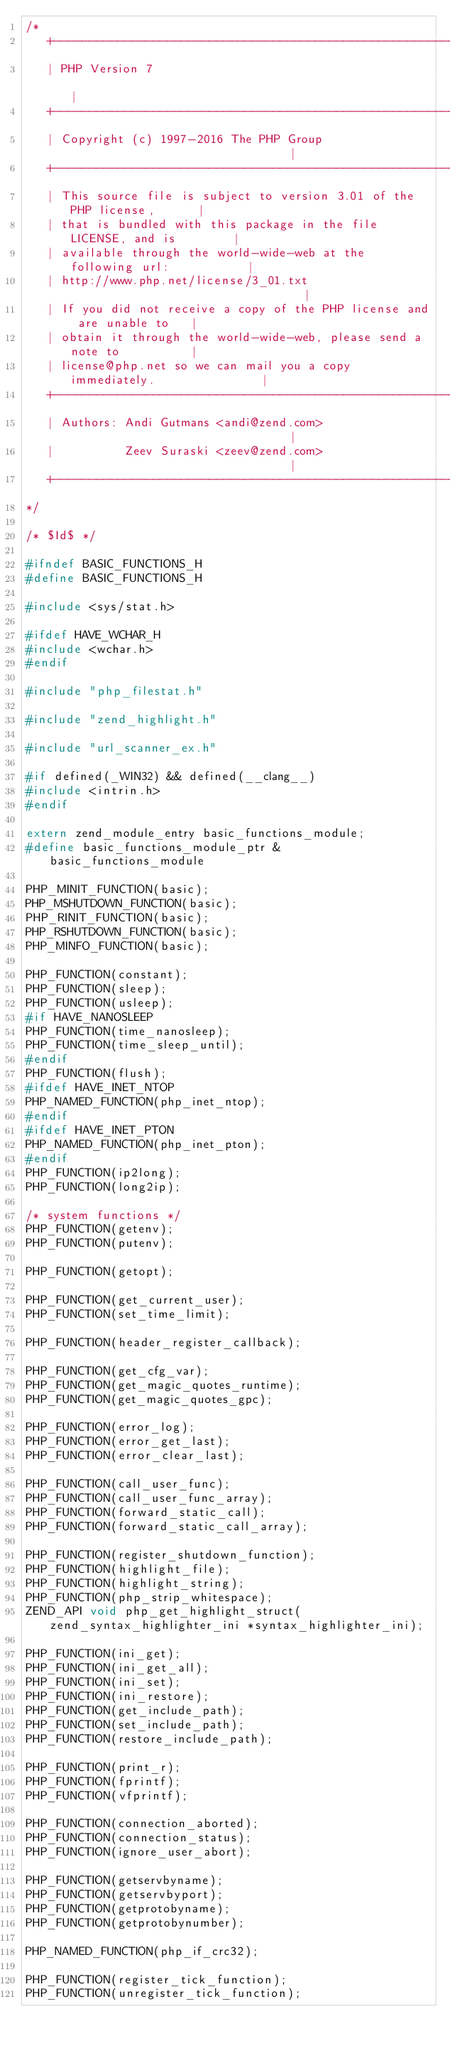<code> <loc_0><loc_0><loc_500><loc_500><_C_>/*
   +----------------------------------------------------------------------+
   | PHP Version 7                                                        |
   +----------------------------------------------------------------------+
   | Copyright (c) 1997-2016 The PHP Group                                |
   +----------------------------------------------------------------------+
   | This source file is subject to version 3.01 of the PHP license,      |
   | that is bundled with this package in the file LICENSE, and is        |
   | available through the world-wide-web at the following url:           |
   | http://www.php.net/license/3_01.txt                                  |
   | If you did not receive a copy of the PHP license and are unable to   |
   | obtain it through the world-wide-web, please send a note to          |
   | license@php.net so we can mail you a copy immediately.               |
   +----------------------------------------------------------------------+
   | Authors: Andi Gutmans <andi@zend.com>                                |
   |          Zeev Suraski <zeev@zend.com>                                |
   +----------------------------------------------------------------------+
*/

/* $Id$ */

#ifndef BASIC_FUNCTIONS_H
#define BASIC_FUNCTIONS_H

#include <sys/stat.h>

#ifdef HAVE_WCHAR_H
#include <wchar.h>
#endif

#include "php_filestat.h"

#include "zend_highlight.h"

#include "url_scanner_ex.h"

#if defined(_WIN32) && defined(__clang__)
#include <intrin.h>
#endif

extern zend_module_entry basic_functions_module;
#define basic_functions_module_ptr &basic_functions_module

PHP_MINIT_FUNCTION(basic);
PHP_MSHUTDOWN_FUNCTION(basic);
PHP_RINIT_FUNCTION(basic);
PHP_RSHUTDOWN_FUNCTION(basic);
PHP_MINFO_FUNCTION(basic);

PHP_FUNCTION(constant);
PHP_FUNCTION(sleep);
PHP_FUNCTION(usleep);
#if HAVE_NANOSLEEP
PHP_FUNCTION(time_nanosleep);
PHP_FUNCTION(time_sleep_until);
#endif
PHP_FUNCTION(flush);
#ifdef HAVE_INET_NTOP
PHP_NAMED_FUNCTION(php_inet_ntop);
#endif
#ifdef HAVE_INET_PTON
PHP_NAMED_FUNCTION(php_inet_pton);
#endif
PHP_FUNCTION(ip2long);
PHP_FUNCTION(long2ip);

/* system functions */
PHP_FUNCTION(getenv);
PHP_FUNCTION(putenv);

PHP_FUNCTION(getopt);

PHP_FUNCTION(get_current_user);
PHP_FUNCTION(set_time_limit);

PHP_FUNCTION(header_register_callback);

PHP_FUNCTION(get_cfg_var);
PHP_FUNCTION(get_magic_quotes_runtime);
PHP_FUNCTION(get_magic_quotes_gpc);

PHP_FUNCTION(error_log);
PHP_FUNCTION(error_get_last);
PHP_FUNCTION(error_clear_last);

PHP_FUNCTION(call_user_func);
PHP_FUNCTION(call_user_func_array);
PHP_FUNCTION(forward_static_call);
PHP_FUNCTION(forward_static_call_array);

PHP_FUNCTION(register_shutdown_function);
PHP_FUNCTION(highlight_file);
PHP_FUNCTION(highlight_string);
PHP_FUNCTION(php_strip_whitespace);
ZEND_API void php_get_highlight_struct(zend_syntax_highlighter_ini *syntax_highlighter_ini);

PHP_FUNCTION(ini_get);
PHP_FUNCTION(ini_get_all);
PHP_FUNCTION(ini_set);
PHP_FUNCTION(ini_restore);
PHP_FUNCTION(get_include_path);
PHP_FUNCTION(set_include_path);
PHP_FUNCTION(restore_include_path);

PHP_FUNCTION(print_r);
PHP_FUNCTION(fprintf);
PHP_FUNCTION(vfprintf);

PHP_FUNCTION(connection_aborted);
PHP_FUNCTION(connection_status);
PHP_FUNCTION(ignore_user_abort);

PHP_FUNCTION(getservbyname);
PHP_FUNCTION(getservbyport);
PHP_FUNCTION(getprotobyname);
PHP_FUNCTION(getprotobynumber);

PHP_NAMED_FUNCTION(php_if_crc32);

PHP_FUNCTION(register_tick_function);
PHP_FUNCTION(unregister_tick_function);</code> 